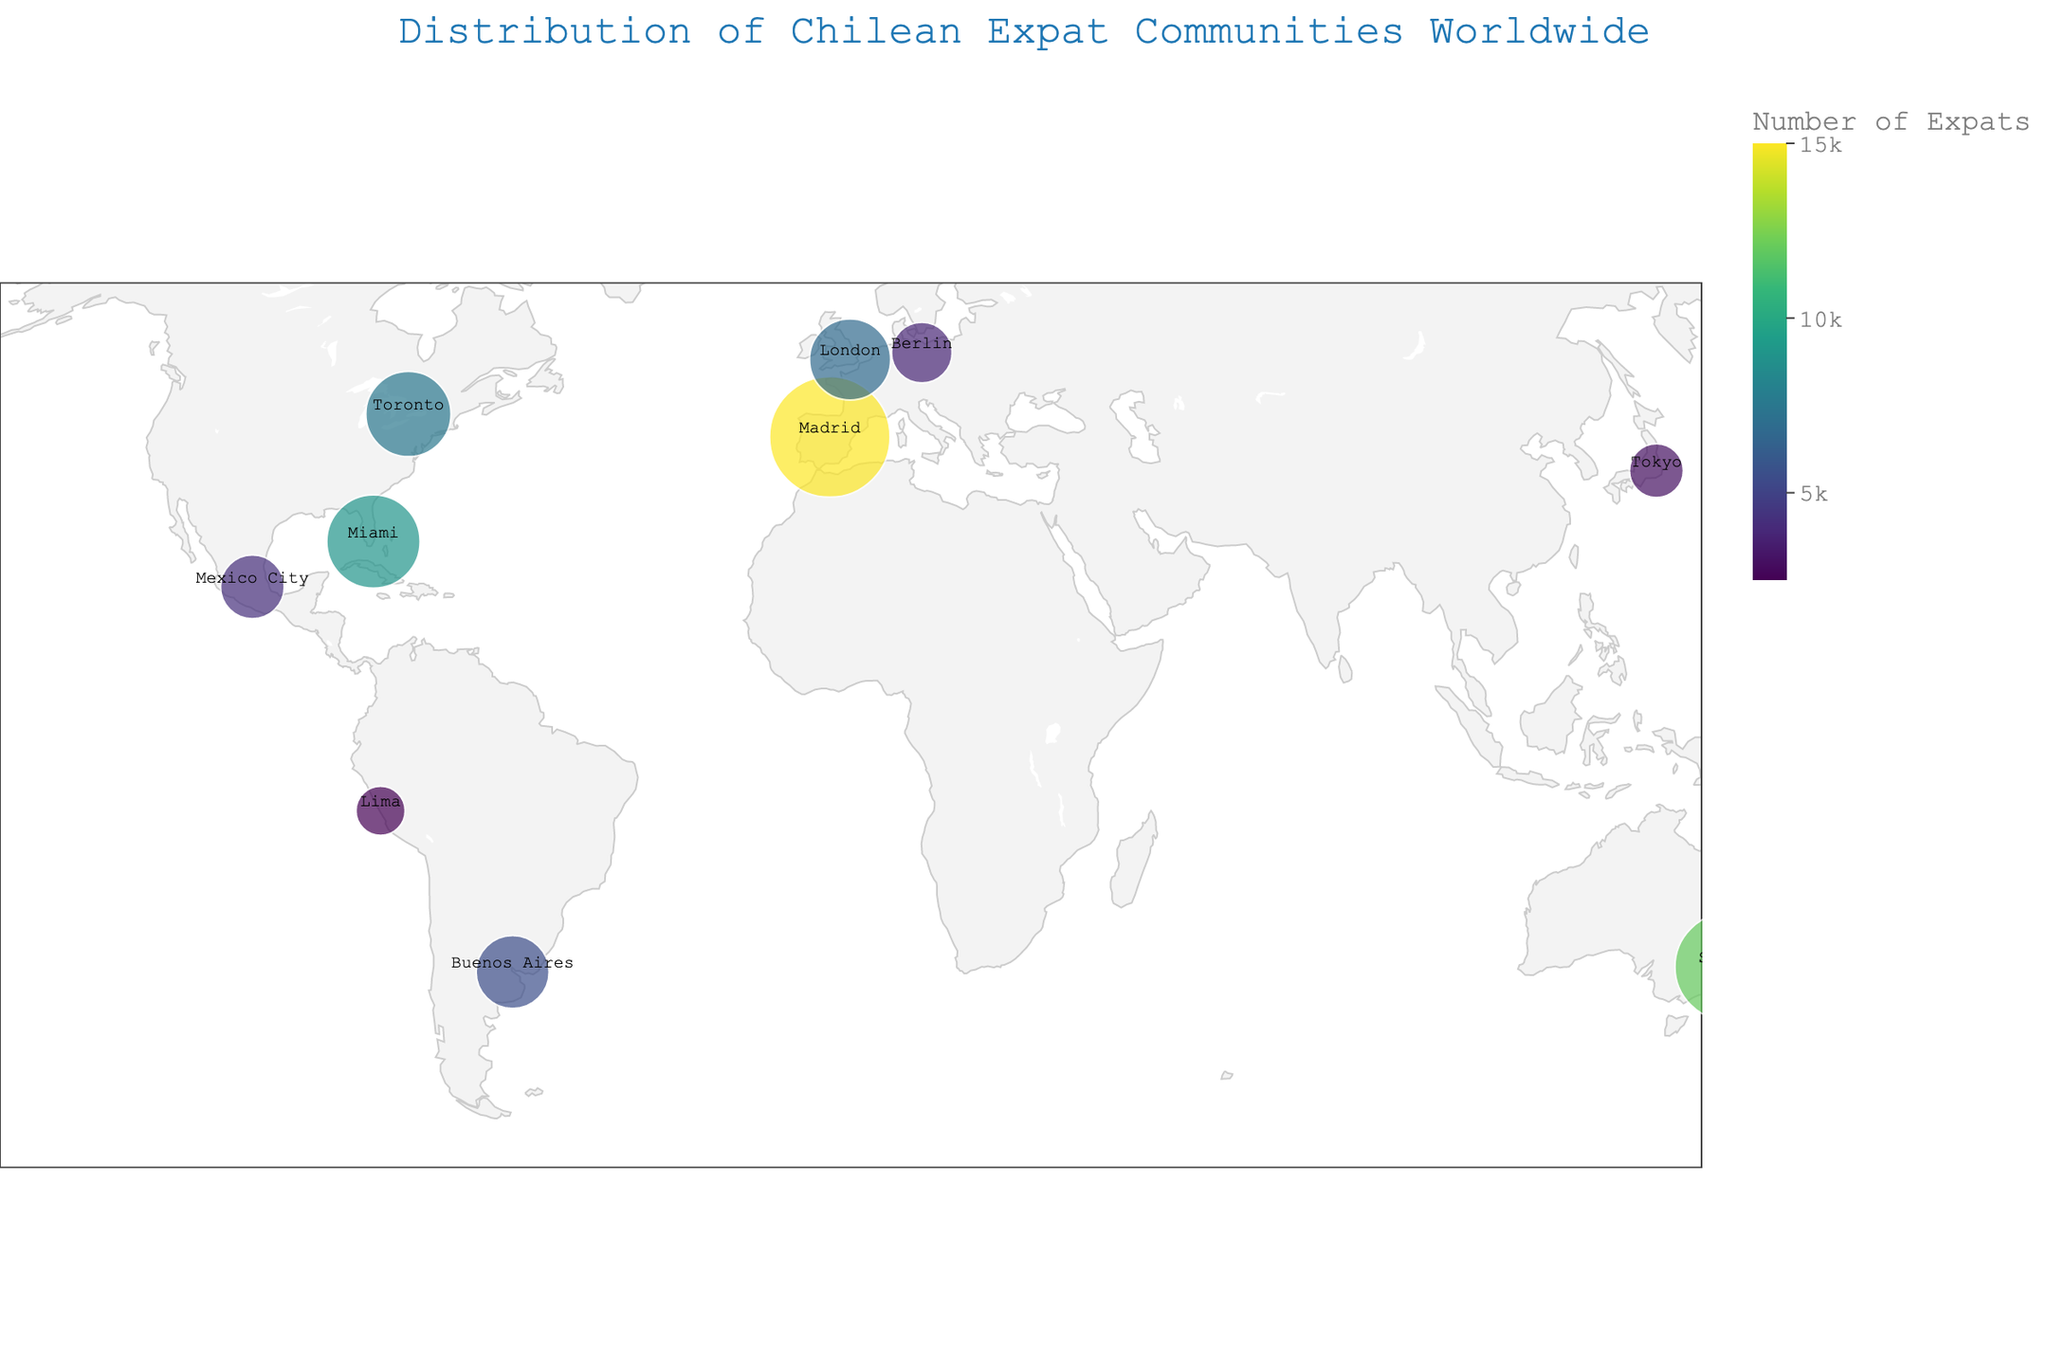What is the title of the figure? The title of the figure is prominently displayed at the top and is usually distinct and easy to identify.
Answer: Distribution of Chilean Expat Communities Worldwide Which city has the largest Chilean expat community? The size of the circles on the map represents the number of Chilean expats in each city. The largest circle corresponds to the highest value.
Answer: Madrid How many Chilean expats are there in Lima? Hovering over or looking at the corresponding point on the map reveals a label with the city's information, including the number of Chilean expats.
Answer: 2500 What is the average number of Chilean expats in all the displayed cities? Sum the total number of Chilean expats and divide by the number of cities (15000+12000+9000+7500+6800+5500+4200+3800+3000+2500) / 10 = 69300 / 10.
Answer: 6930 Which city has fewer Chilean expats, Sydney or Miami? By comparing the numbers next to their corresponding cities, we see that Sydney has 12000 and Miami has 9000.
Answer: Miami How does the number of Chilean expats in London compare to those in Toronto? Comparing the values directly, London has 6800 and Toronto has 7500. Toronto has more expats.
Answer: London has fewer expats than Toronto Which continents host the majority of Chilean expat communities? Observing the geographic distribution of the points, most are located in Europe, North America, and Oceania.
Answer: Europe, North America, and Oceania Name the countries in South America with significant Chilean expat communities. By identifying the cities on the map that are located in South America and checking their corresponding country labels, we find Buenos Aires in Argentina and Lima in Peru.
Answer: Argentina and Peru What color scheme is used to represent the number of Chilean expats? The color scheme on the map is usually indicated in a legend or can be visually inferred. In this case, it uses a Viridis color scale, progressing from dark to bright.
Answer: Viridis What is the total number of Chilean expats in all the listed cities combined? Adding up all the numbers associated with each city on the map (15000 + 12000 + 9000 + 7500 + 6800 + 5500 + 4200 + 3800 + 3000 + 2500).
Answer: 69300 